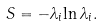Convert formula to latex. <formula><loc_0><loc_0><loc_500><loc_500>S = - { { \lambda } _ { i } { \ln { \lambda } _ { i } } } .</formula> 